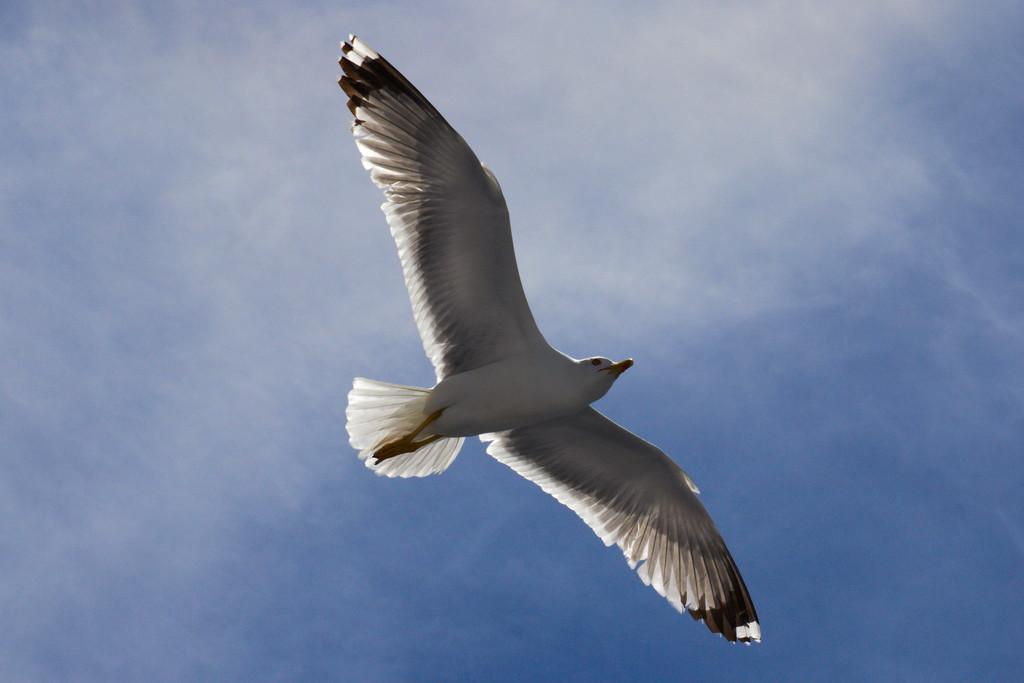How would you summarize this image in a sentence or two? In this image there is a bird flying in the air. 